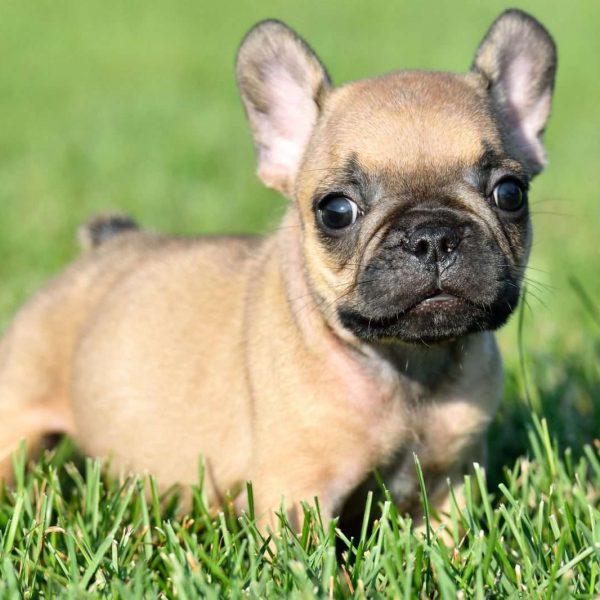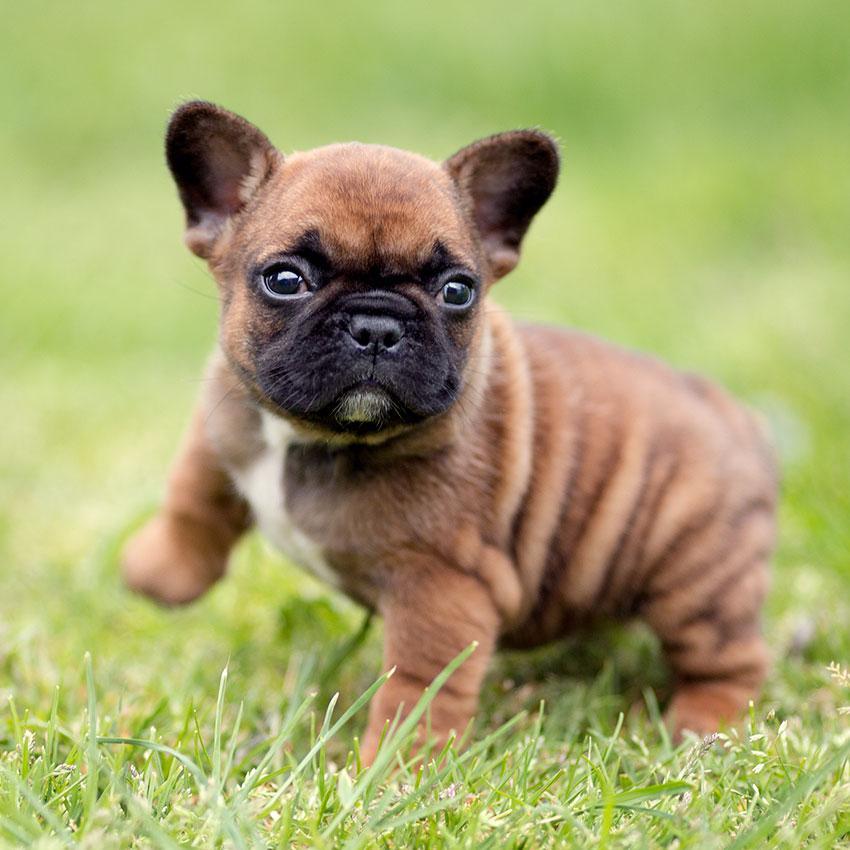The first image is the image on the left, the second image is the image on the right. Given the left and right images, does the statement "At least one image features a puppy on the grass." hold true? Answer yes or no. Yes. 